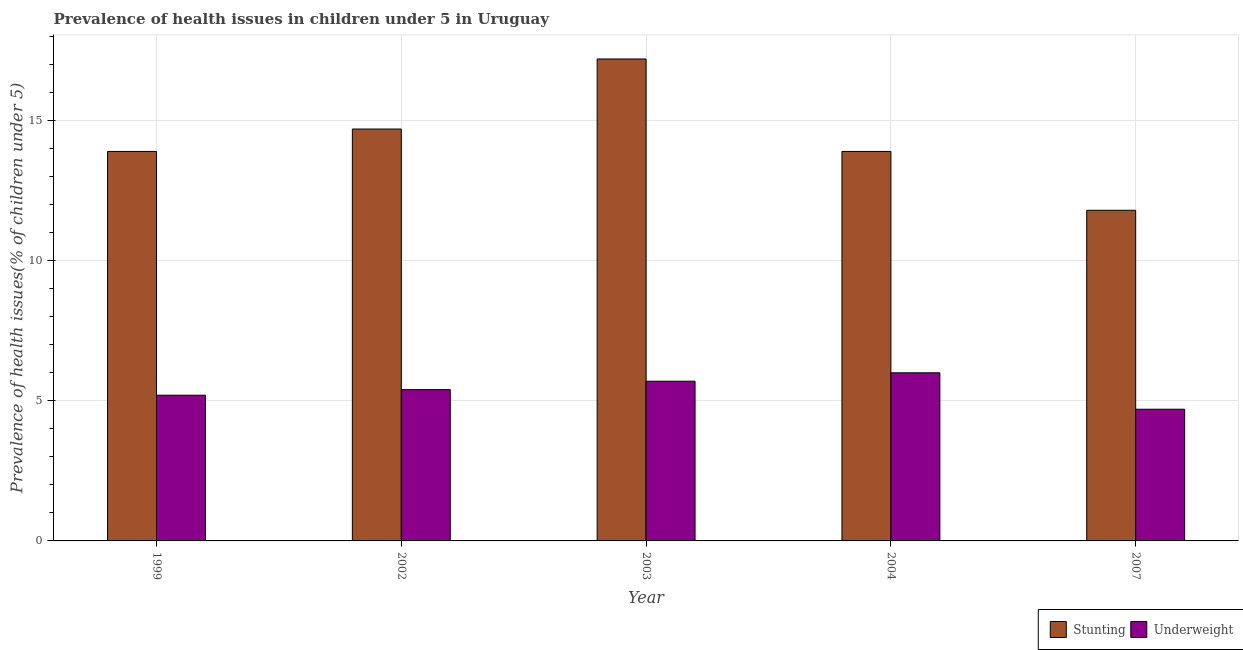How many different coloured bars are there?
Give a very brief answer. 2. In how many cases, is the number of bars for a given year not equal to the number of legend labels?
Make the answer very short. 0. What is the percentage of stunted children in 2003?
Provide a short and direct response. 17.2. Across all years, what is the maximum percentage of stunted children?
Ensure brevity in your answer.  17.2. Across all years, what is the minimum percentage of stunted children?
Offer a terse response. 11.8. In which year was the percentage of underweight children maximum?
Your answer should be compact. 2004. In which year was the percentage of underweight children minimum?
Keep it short and to the point. 2007. What is the total percentage of underweight children in the graph?
Your response must be concise. 27. What is the difference between the percentage of underweight children in 2003 and that in 2007?
Keep it short and to the point. 1. What is the difference between the percentage of underweight children in 2007 and the percentage of stunted children in 2002?
Give a very brief answer. -0.7. What is the average percentage of underweight children per year?
Provide a short and direct response. 5.4. In the year 1999, what is the difference between the percentage of stunted children and percentage of underweight children?
Make the answer very short. 0. What is the ratio of the percentage of underweight children in 2002 to that in 2003?
Provide a succinct answer. 0.95. Is the difference between the percentage of underweight children in 1999 and 2004 greater than the difference between the percentage of stunted children in 1999 and 2004?
Make the answer very short. No. What is the difference between the highest and the second highest percentage of underweight children?
Your answer should be very brief. 0.3. What is the difference between the highest and the lowest percentage of stunted children?
Provide a short and direct response. 5.4. In how many years, is the percentage of underweight children greater than the average percentage of underweight children taken over all years?
Provide a short and direct response. 3. Is the sum of the percentage of underweight children in 1999 and 2007 greater than the maximum percentage of stunted children across all years?
Your answer should be compact. Yes. What does the 2nd bar from the left in 2003 represents?
Your response must be concise. Underweight. What does the 2nd bar from the right in 2002 represents?
Provide a succinct answer. Stunting. How many years are there in the graph?
Your answer should be very brief. 5. What is the difference between two consecutive major ticks on the Y-axis?
Give a very brief answer. 5. Are the values on the major ticks of Y-axis written in scientific E-notation?
Keep it short and to the point. No. Does the graph contain any zero values?
Make the answer very short. No. Does the graph contain grids?
Your answer should be compact. Yes. How are the legend labels stacked?
Your answer should be very brief. Horizontal. What is the title of the graph?
Your answer should be compact. Prevalence of health issues in children under 5 in Uruguay. Does "Manufacturing industries and construction" appear as one of the legend labels in the graph?
Provide a short and direct response. No. What is the label or title of the X-axis?
Your answer should be very brief. Year. What is the label or title of the Y-axis?
Your response must be concise. Prevalence of health issues(% of children under 5). What is the Prevalence of health issues(% of children under 5) of Stunting in 1999?
Offer a very short reply. 13.9. What is the Prevalence of health issues(% of children under 5) in Underweight in 1999?
Ensure brevity in your answer.  5.2. What is the Prevalence of health issues(% of children under 5) of Stunting in 2002?
Your response must be concise. 14.7. What is the Prevalence of health issues(% of children under 5) of Underweight in 2002?
Keep it short and to the point. 5.4. What is the Prevalence of health issues(% of children under 5) of Stunting in 2003?
Provide a succinct answer. 17.2. What is the Prevalence of health issues(% of children under 5) of Underweight in 2003?
Your answer should be very brief. 5.7. What is the Prevalence of health issues(% of children under 5) in Stunting in 2004?
Make the answer very short. 13.9. What is the Prevalence of health issues(% of children under 5) in Underweight in 2004?
Ensure brevity in your answer.  6. What is the Prevalence of health issues(% of children under 5) in Stunting in 2007?
Ensure brevity in your answer.  11.8. What is the Prevalence of health issues(% of children under 5) of Underweight in 2007?
Your response must be concise. 4.7. Across all years, what is the maximum Prevalence of health issues(% of children under 5) in Stunting?
Make the answer very short. 17.2. Across all years, what is the maximum Prevalence of health issues(% of children under 5) in Underweight?
Ensure brevity in your answer.  6. Across all years, what is the minimum Prevalence of health issues(% of children under 5) of Stunting?
Offer a terse response. 11.8. Across all years, what is the minimum Prevalence of health issues(% of children under 5) of Underweight?
Keep it short and to the point. 4.7. What is the total Prevalence of health issues(% of children under 5) of Stunting in the graph?
Provide a succinct answer. 71.5. What is the difference between the Prevalence of health issues(% of children under 5) of Underweight in 1999 and that in 2002?
Provide a short and direct response. -0.2. What is the difference between the Prevalence of health issues(% of children under 5) in Underweight in 1999 and that in 2003?
Offer a very short reply. -0.5. What is the difference between the Prevalence of health issues(% of children under 5) in Underweight in 1999 and that in 2007?
Provide a short and direct response. 0.5. What is the difference between the Prevalence of health issues(% of children under 5) of Stunting in 2002 and that in 2007?
Provide a succinct answer. 2.9. What is the difference between the Prevalence of health issues(% of children under 5) in Underweight in 2002 and that in 2007?
Make the answer very short. 0.7. What is the difference between the Prevalence of health issues(% of children under 5) of Underweight in 2003 and that in 2004?
Your response must be concise. -0.3. What is the difference between the Prevalence of health issues(% of children under 5) in Stunting in 2003 and that in 2007?
Provide a short and direct response. 5.4. What is the difference between the Prevalence of health issues(% of children under 5) of Stunting in 2004 and that in 2007?
Ensure brevity in your answer.  2.1. What is the difference between the Prevalence of health issues(% of children under 5) of Stunting in 1999 and the Prevalence of health issues(% of children under 5) of Underweight in 2003?
Your answer should be compact. 8.2. What is the difference between the Prevalence of health issues(% of children under 5) of Stunting in 1999 and the Prevalence of health issues(% of children under 5) of Underweight in 2004?
Provide a succinct answer. 7.9. What is the difference between the Prevalence of health issues(% of children under 5) of Stunting in 1999 and the Prevalence of health issues(% of children under 5) of Underweight in 2007?
Ensure brevity in your answer.  9.2. What is the difference between the Prevalence of health issues(% of children under 5) of Stunting in 2002 and the Prevalence of health issues(% of children under 5) of Underweight in 2004?
Offer a very short reply. 8.7. What is the difference between the Prevalence of health issues(% of children under 5) of Stunting in 2003 and the Prevalence of health issues(% of children under 5) of Underweight in 2004?
Provide a short and direct response. 11.2. What is the difference between the Prevalence of health issues(% of children under 5) of Stunting in 2004 and the Prevalence of health issues(% of children under 5) of Underweight in 2007?
Your answer should be very brief. 9.2. In the year 1999, what is the difference between the Prevalence of health issues(% of children under 5) of Stunting and Prevalence of health issues(% of children under 5) of Underweight?
Your response must be concise. 8.7. In the year 2002, what is the difference between the Prevalence of health issues(% of children under 5) of Stunting and Prevalence of health issues(% of children under 5) of Underweight?
Your response must be concise. 9.3. In the year 2003, what is the difference between the Prevalence of health issues(% of children under 5) in Stunting and Prevalence of health issues(% of children under 5) in Underweight?
Your answer should be very brief. 11.5. What is the ratio of the Prevalence of health issues(% of children under 5) in Stunting in 1999 to that in 2002?
Your response must be concise. 0.95. What is the ratio of the Prevalence of health issues(% of children under 5) in Underweight in 1999 to that in 2002?
Offer a very short reply. 0.96. What is the ratio of the Prevalence of health issues(% of children under 5) in Stunting in 1999 to that in 2003?
Make the answer very short. 0.81. What is the ratio of the Prevalence of health issues(% of children under 5) in Underweight in 1999 to that in 2003?
Keep it short and to the point. 0.91. What is the ratio of the Prevalence of health issues(% of children under 5) in Stunting in 1999 to that in 2004?
Offer a very short reply. 1. What is the ratio of the Prevalence of health issues(% of children under 5) in Underweight in 1999 to that in 2004?
Offer a very short reply. 0.87. What is the ratio of the Prevalence of health issues(% of children under 5) of Stunting in 1999 to that in 2007?
Give a very brief answer. 1.18. What is the ratio of the Prevalence of health issues(% of children under 5) of Underweight in 1999 to that in 2007?
Provide a short and direct response. 1.11. What is the ratio of the Prevalence of health issues(% of children under 5) in Stunting in 2002 to that in 2003?
Provide a succinct answer. 0.85. What is the ratio of the Prevalence of health issues(% of children under 5) in Underweight in 2002 to that in 2003?
Ensure brevity in your answer.  0.95. What is the ratio of the Prevalence of health issues(% of children under 5) of Stunting in 2002 to that in 2004?
Give a very brief answer. 1.06. What is the ratio of the Prevalence of health issues(% of children under 5) of Stunting in 2002 to that in 2007?
Your answer should be compact. 1.25. What is the ratio of the Prevalence of health issues(% of children under 5) in Underweight in 2002 to that in 2007?
Ensure brevity in your answer.  1.15. What is the ratio of the Prevalence of health issues(% of children under 5) in Stunting in 2003 to that in 2004?
Provide a succinct answer. 1.24. What is the ratio of the Prevalence of health issues(% of children under 5) in Stunting in 2003 to that in 2007?
Your answer should be compact. 1.46. What is the ratio of the Prevalence of health issues(% of children under 5) of Underweight in 2003 to that in 2007?
Provide a short and direct response. 1.21. What is the ratio of the Prevalence of health issues(% of children under 5) in Stunting in 2004 to that in 2007?
Offer a terse response. 1.18. What is the ratio of the Prevalence of health issues(% of children under 5) in Underweight in 2004 to that in 2007?
Offer a terse response. 1.28. What is the difference between the highest and the lowest Prevalence of health issues(% of children under 5) of Underweight?
Offer a terse response. 1.3. 